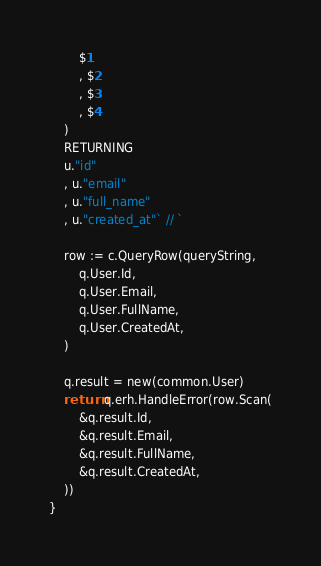Convert code to text. <code><loc_0><loc_0><loc_500><loc_500><_Go_>		$1
		, $2
		, $3
		, $4
	)
	RETURNING
	u."id"
	, u."email"
	, u."full_name"
	, u."created_at"` // `

	row := c.QueryRow(queryString,
		q.User.Id,
		q.User.Email,
		q.User.FullName,
		q.User.CreatedAt,
	)

	q.result = new(common.User)
	return q.erh.HandleError(row.Scan(
		&q.result.Id,
		&q.result.Email,
		&q.result.FullName,
		&q.result.CreatedAt,
	))
}
</code> 